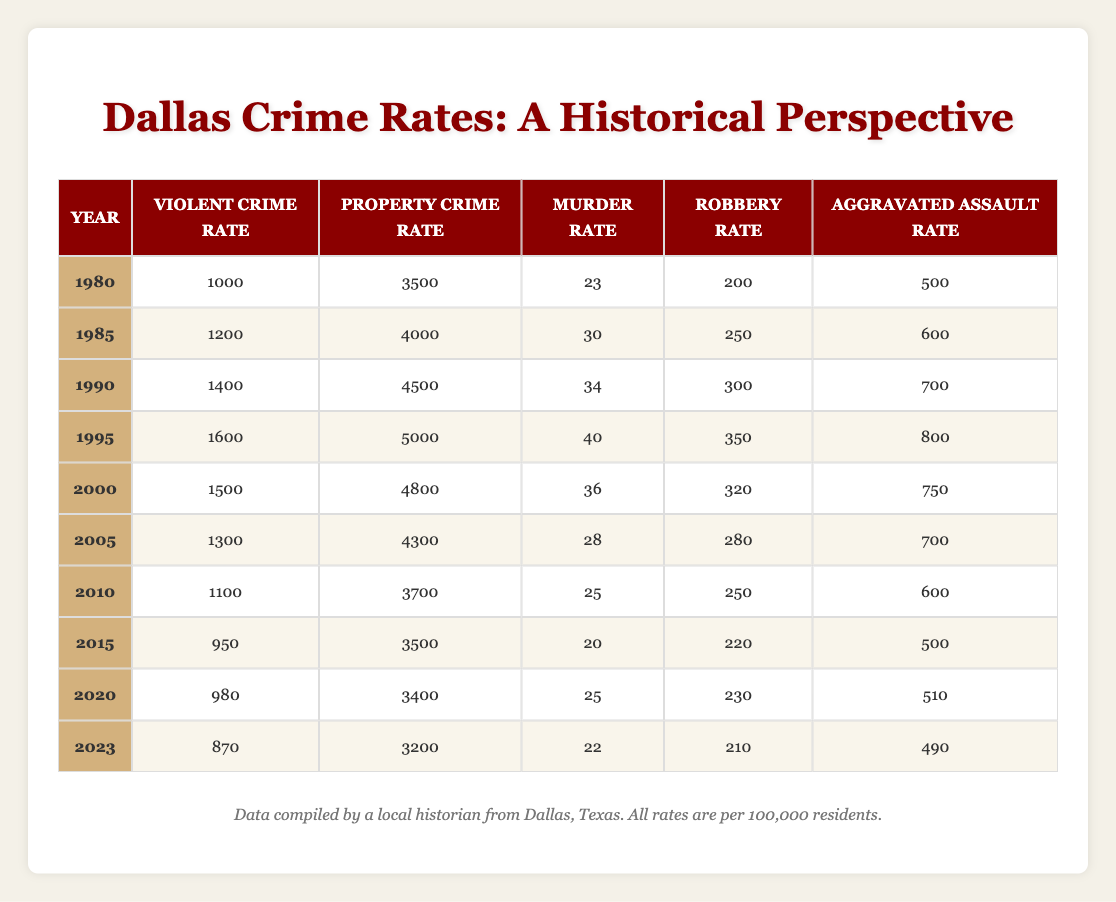What was the violent crime rate in 1995? The table shows that in 1995, the violent crime rate was 1600 per 100,000 residents.
Answer: 1600 How many murder cases per 100,000 residents were reported in 2010 compared to 2023? In 2010, the murder rate was 25, and in 2023, it was 22. Comparing these figures shows that 25 - 22 = 3 fewer murders per 100,000 residents in 2023 than in 2010.
Answer: 3 fewer Which year had the highest property crime rate? The table indicates that the highest property crime rate was in 1995, at 5000 per 100,000 residents.
Answer: 1995 Did the aggravated assault rate decrease from 2005 to 2020? In 2005, the aggravated assault rate was 700 and in 2020 it was 510. Since 700 > 510, this indicates a decrease.
Answer: Yes What is the average murder rate from 1980 to 2023? To find the average, we sum the murder rates (23 + 30 + 34 + 40 + 36 + 28 + 25 + 20 + 25 + 22 =  333) and divide by the number of years (10). Thus, the average murder rate is 333 / 10 = 33.3.
Answer: 33.3 